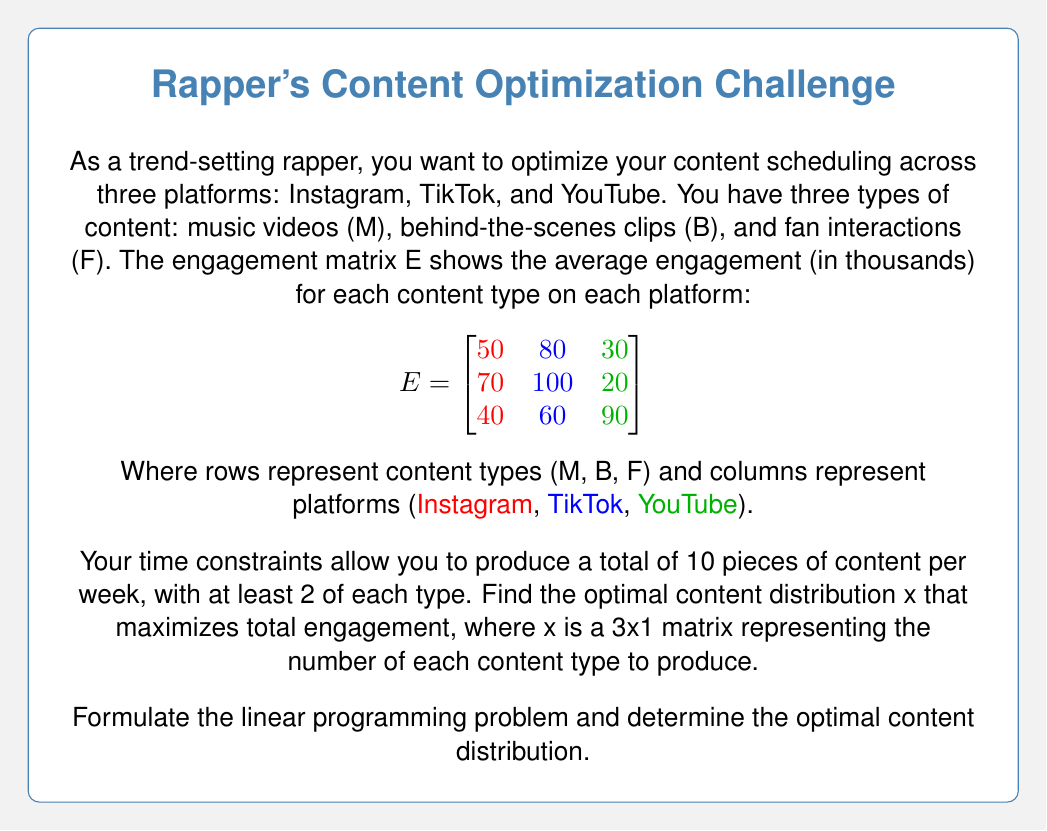What is the answer to this math problem? Let's approach this step-by-step:

1) First, we need to set up our objective function. We want to maximize total engagement, which is the sum of the product of each content type with its corresponding engagement across all platforms. This can be represented as:

   $$\text{Maximize } z = [50 + 80 + 30, 70 + 100 + 20, 40 + 60 + 90] \cdot x$$
   $$= [160, 190, 190] \cdot x$$

2) Now, we set up our constraints:
   - Total content: $x_1 + x_2 + x_3 = 10$
   - Minimum 2 of each type: $x_1 \geq 2, x_2 \geq 2, x_3 \geq 2$
   - Non-negativity: $x_1, x_2, x_3 \geq 0$

3) Our linear programming problem is now:

   Maximize $z = 160x_1 + 190x_2 + 190x_3$
   Subject to:
   $x_1 + x_2 + x_3 = 10$
   $x_1 \geq 2, x_2 \geq 2, x_3 \geq 2$
   $x_1, x_2, x_3 \geq 0$

4) Given the constraints, we have 4 units to distribute among the content types after allocating the minimum 2 to each. Since the coefficients for $x_2$ and $x_3$ are equal and larger than $x_1$, we should allocate these 4 units to $x_2$ and $x_3$ equally.

5) Therefore, the optimal distribution is:
   $x_1 = 2$ (Music videos)
   $x_2 = 4$ (Behind-the-scenes clips)
   $x_3 = 4$ (Fan interactions)

6) We can verify this satisfies all constraints:
   $2 + 4 + 4 = 10$
   All values are $\geq 2$ and non-negative

7) The maximum engagement achieved is:
   $z = 160(2) + 190(4) + 190(4) = 320 + 760 + 760 = 1840$ thousand engagements
Answer: $$x = \begin{bmatrix} 2 \\ 4 \\ 4 \end{bmatrix}$$ 